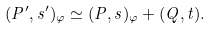Convert formula to latex. <formula><loc_0><loc_0><loc_500><loc_500>( P ^ { \prime } , s ^ { \prime } ) _ { \varphi } \simeq ( P , s ) _ { \varphi } + ( Q , t ) .</formula> 